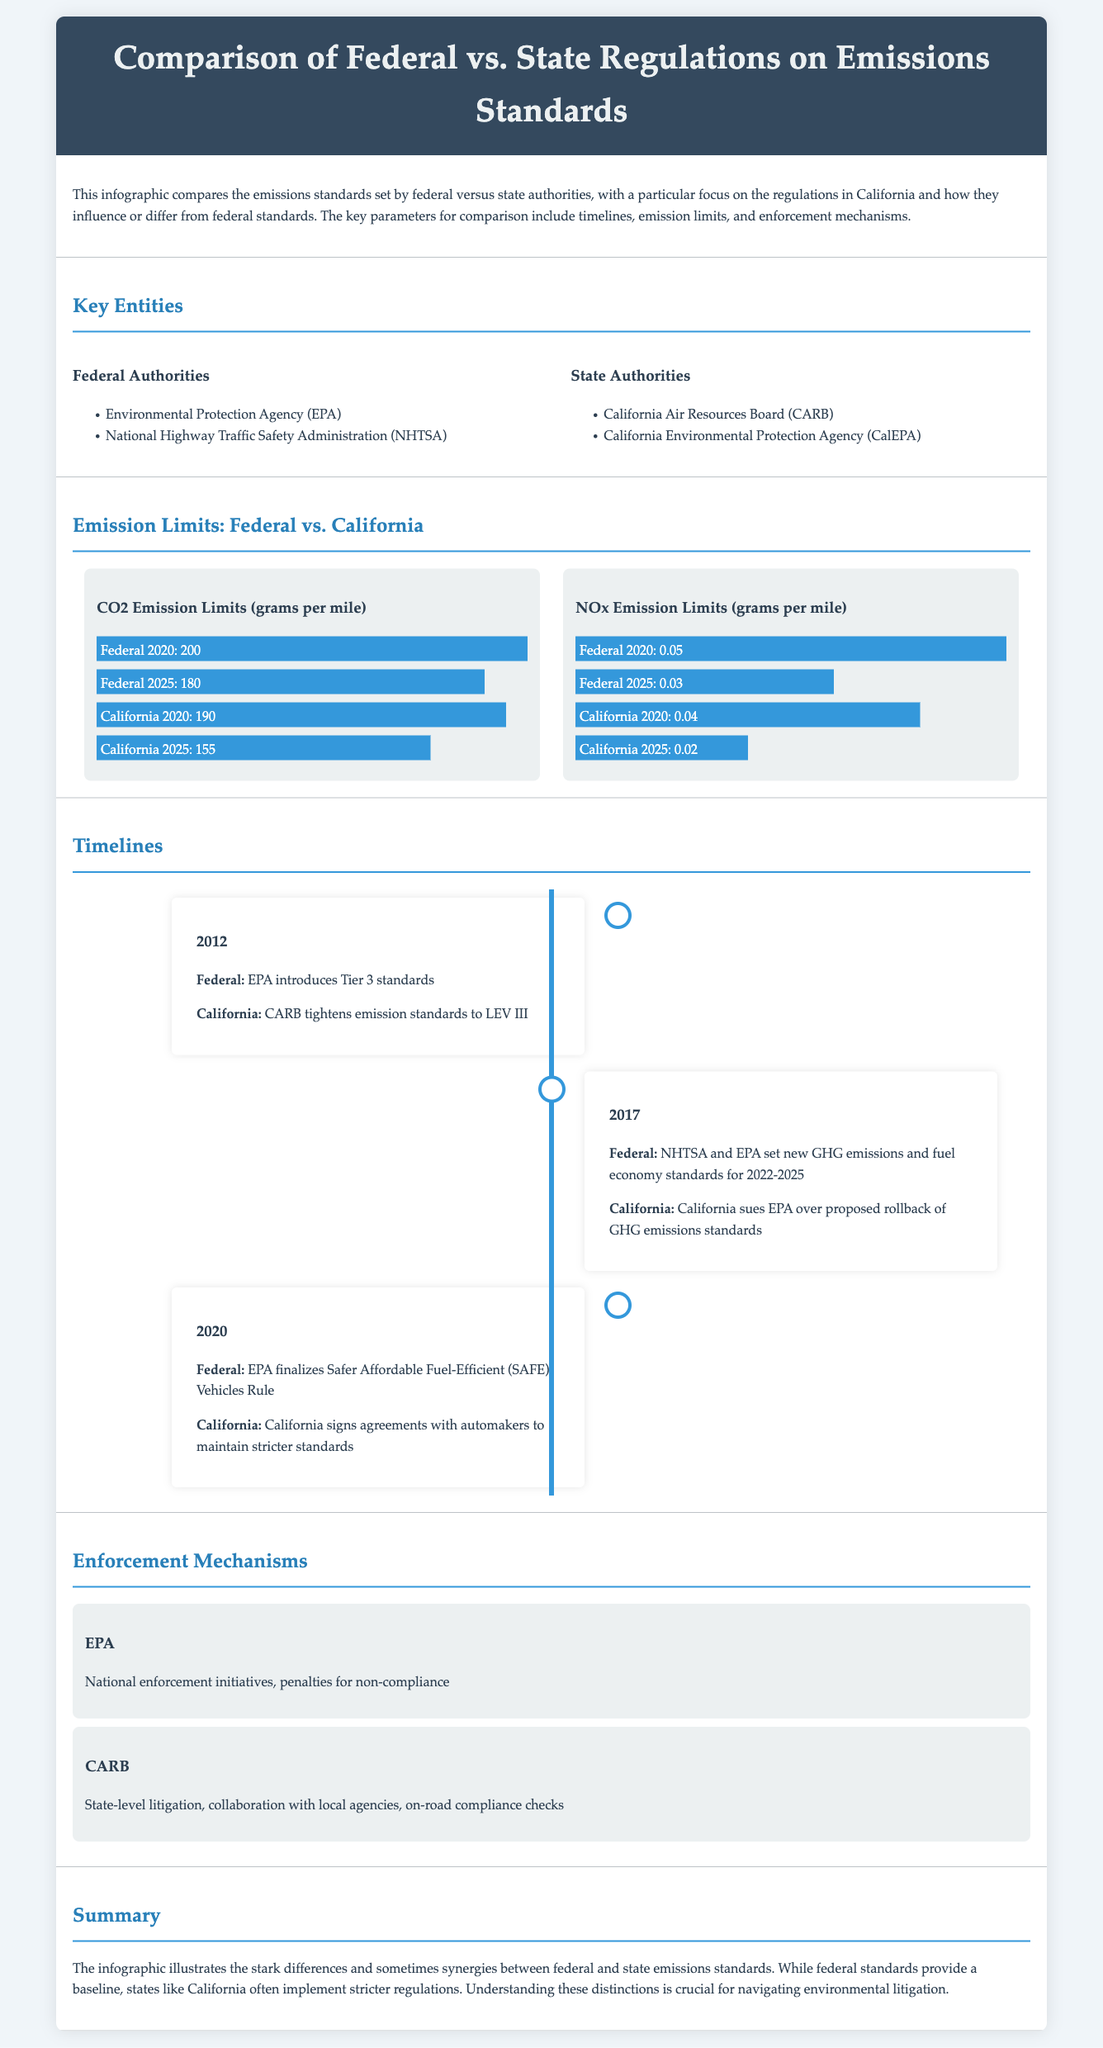What is the main title of the infographic? The main title appears prominently at the top of the document and summarizes the subject of the infographic, which is the comparison of emissions regulations.
Answer: Comparison of Federal vs. State Regulations on Emissions Standards Which federal authority is mentioned first? The infographic lists federal authorities in a specific order, with the first mentioned being the Environmental Protection Agency.
Answer: Environmental Protection Agency (EPA) What is California's NOx emission limit for 2025? The infographic provides specific figures for California's emissions limits for different years, and for 2025 it states the NOx limit is 0.02.
Answer: 0.02 In what year did the EPA introduce Tier 3 standards? The timeline section details significant events related to emissions regulations, indicating that the EPA introduced Tier 3 standards in 2012.
Answer: 2012 How does California's CO2 limit for 2025 compare to the federal limit? The infographic illustrates the comparison of CO2 limits for 2025, indicating California has a stricter limit than the federal limit.
Answer: Stricter What enforcement mechanism does CARB utilize? The document outlines enforcement mechanisms for different authorities, highlighting that CARB uses state-level litigation as one of its strategies.
Answer: State-level litigation What is the key focus of the infographic? The introductory section provides insight into the primary purpose of the infographic, summarizing the relationship and differences between federal and state emission standards.
Answer: Emissions standards comparison What color represents federal limits in the bar charts? The bar charts visually differentiate emission limits by color, with the color blue representing federal limits.
Answer: Blue 